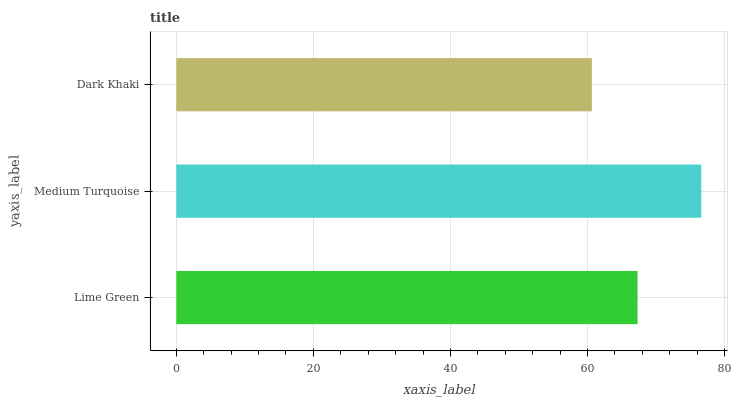Is Dark Khaki the minimum?
Answer yes or no. Yes. Is Medium Turquoise the maximum?
Answer yes or no. Yes. Is Medium Turquoise the minimum?
Answer yes or no. No. Is Dark Khaki the maximum?
Answer yes or no. No. Is Medium Turquoise greater than Dark Khaki?
Answer yes or no. Yes. Is Dark Khaki less than Medium Turquoise?
Answer yes or no. Yes. Is Dark Khaki greater than Medium Turquoise?
Answer yes or no. No. Is Medium Turquoise less than Dark Khaki?
Answer yes or no. No. Is Lime Green the high median?
Answer yes or no. Yes. Is Lime Green the low median?
Answer yes or no. Yes. Is Dark Khaki the high median?
Answer yes or no. No. Is Dark Khaki the low median?
Answer yes or no. No. 